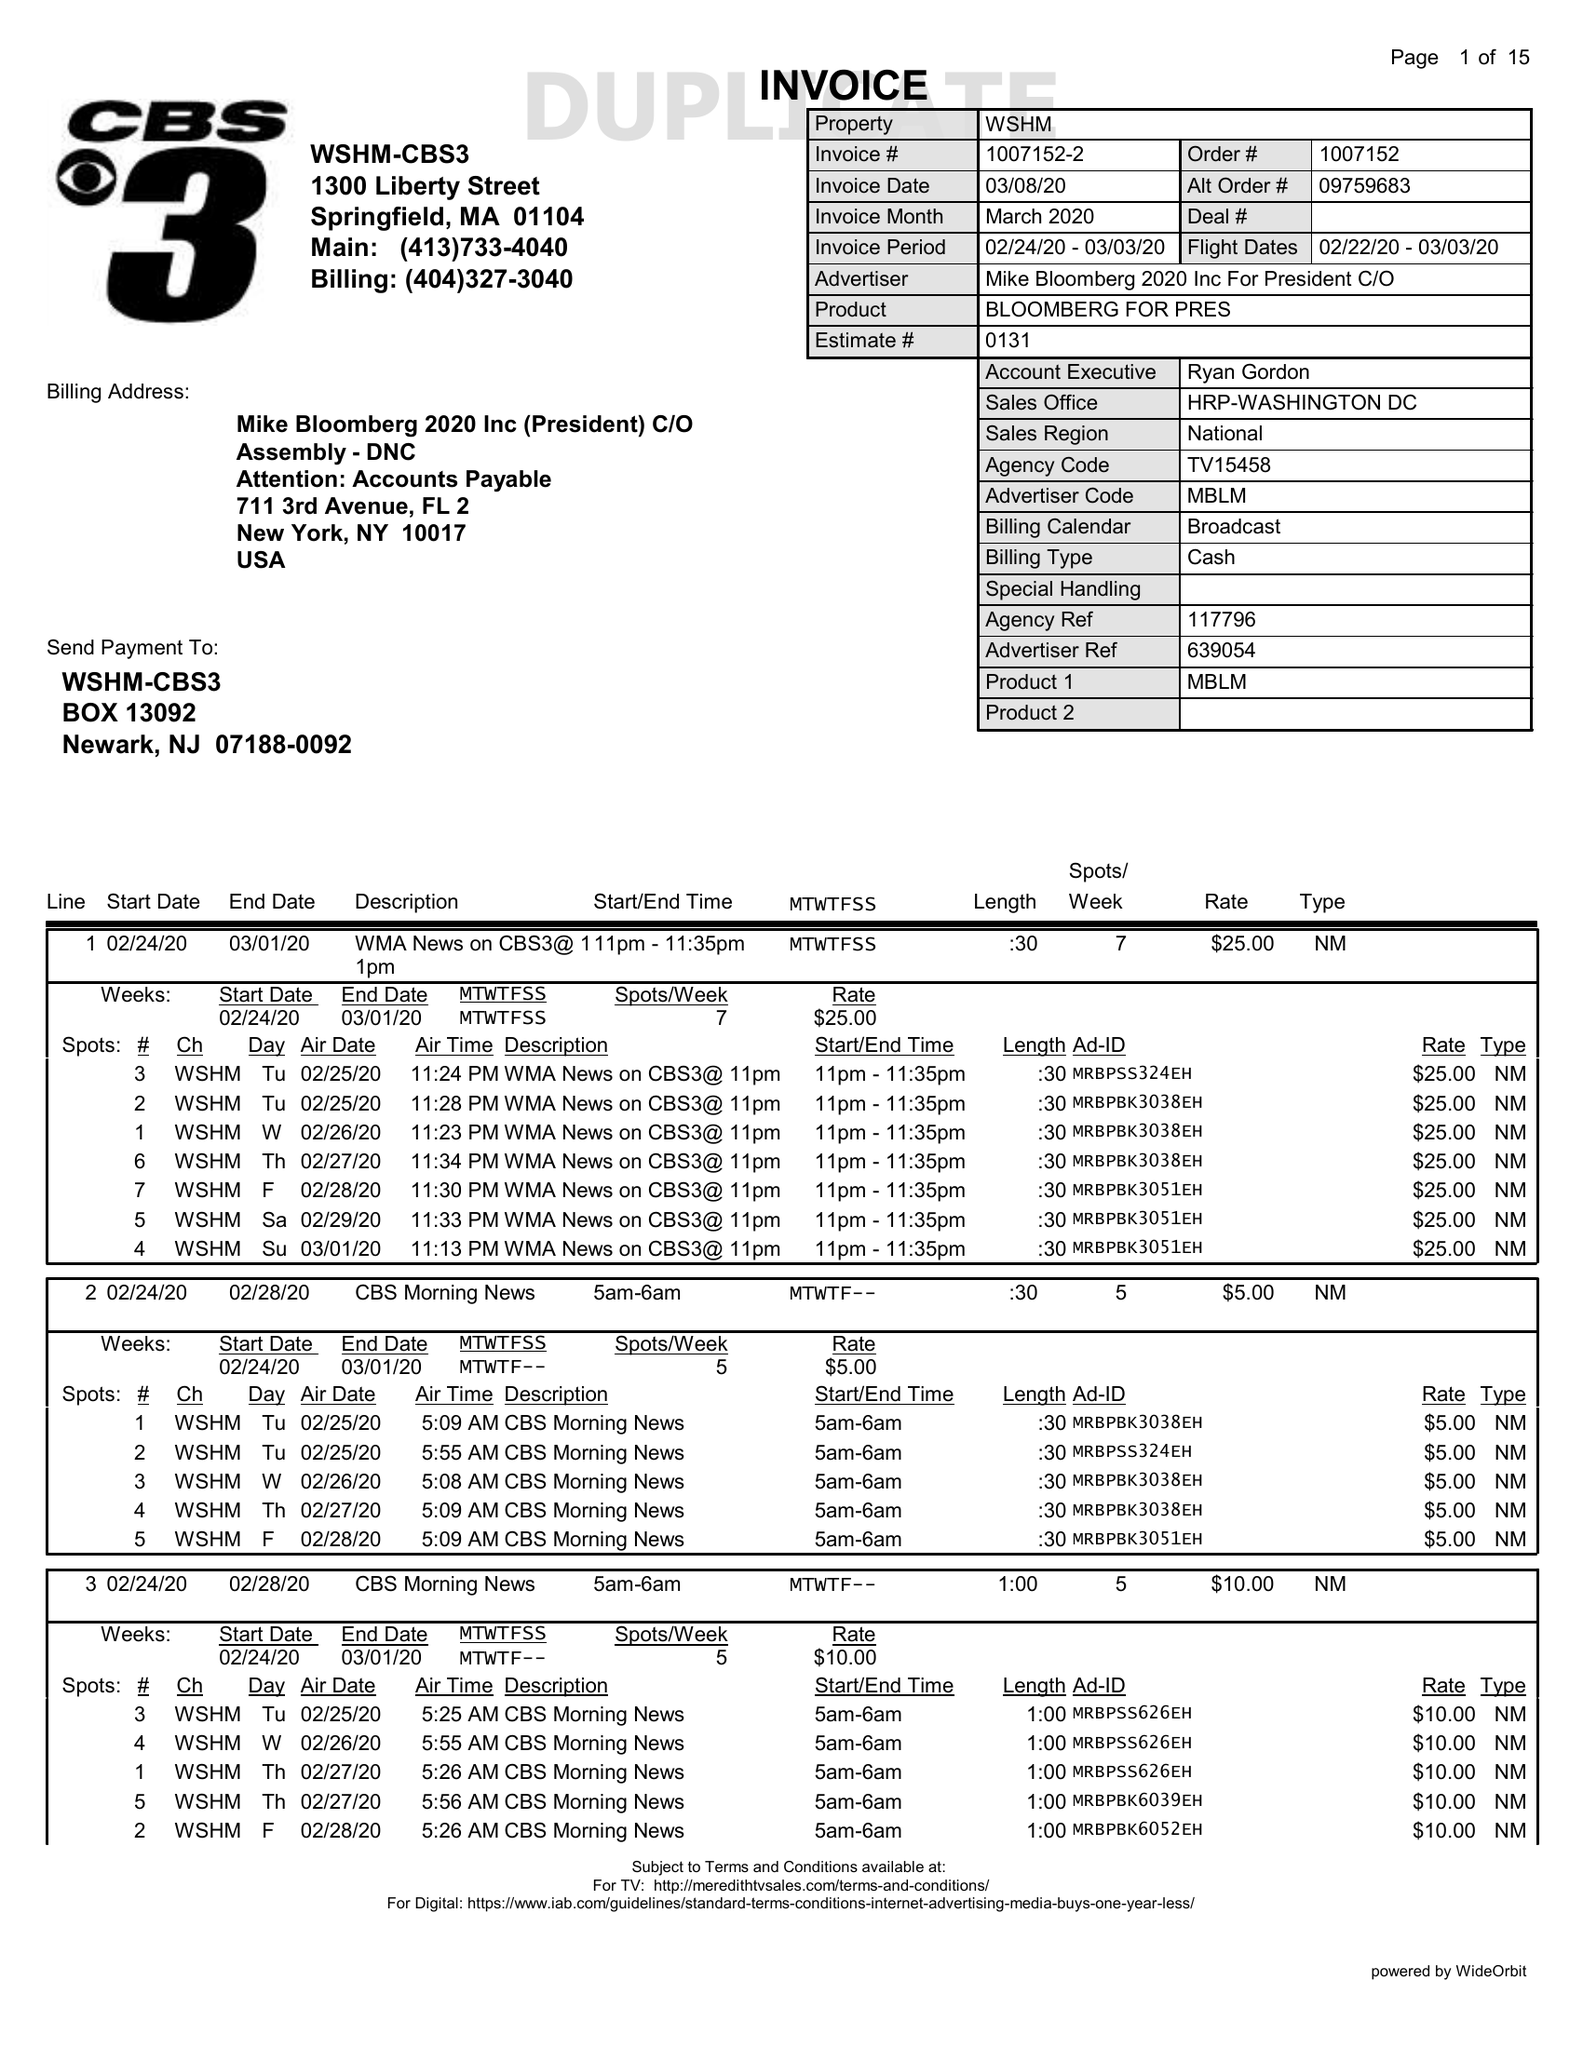What is the value for the advertiser?
Answer the question using a single word or phrase. MIKEBLOOMBERG2020INCFORPRESIDENTC/O 